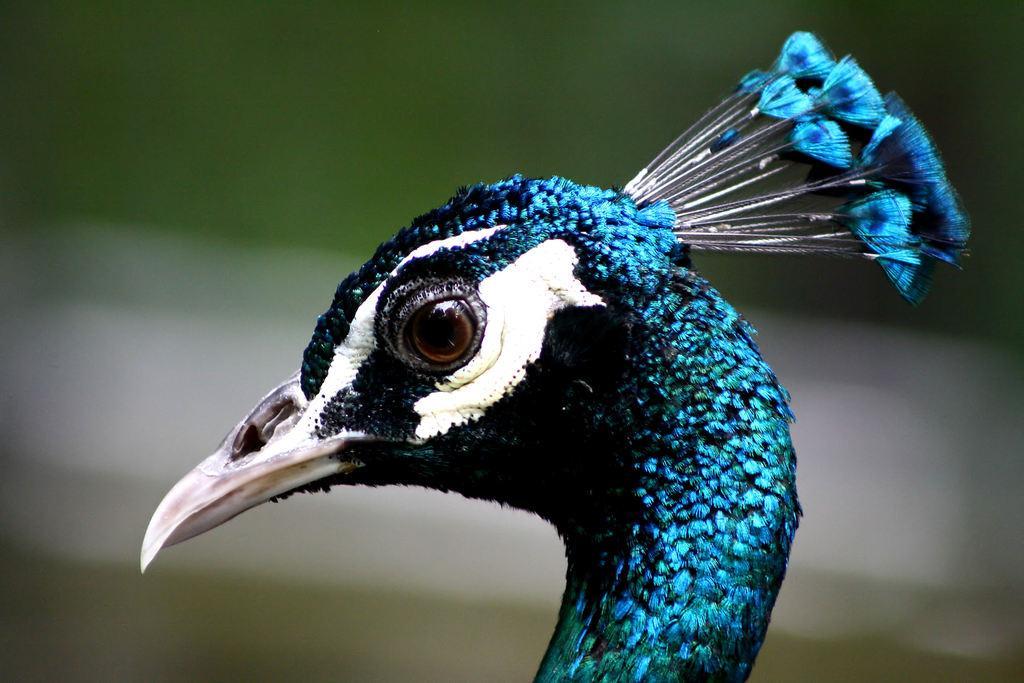How would you summarize this image in a sentence or two? In this image I can see a peacock which is facing towards the left side. On the head, I can see crest in blue color. The background is blurred. 